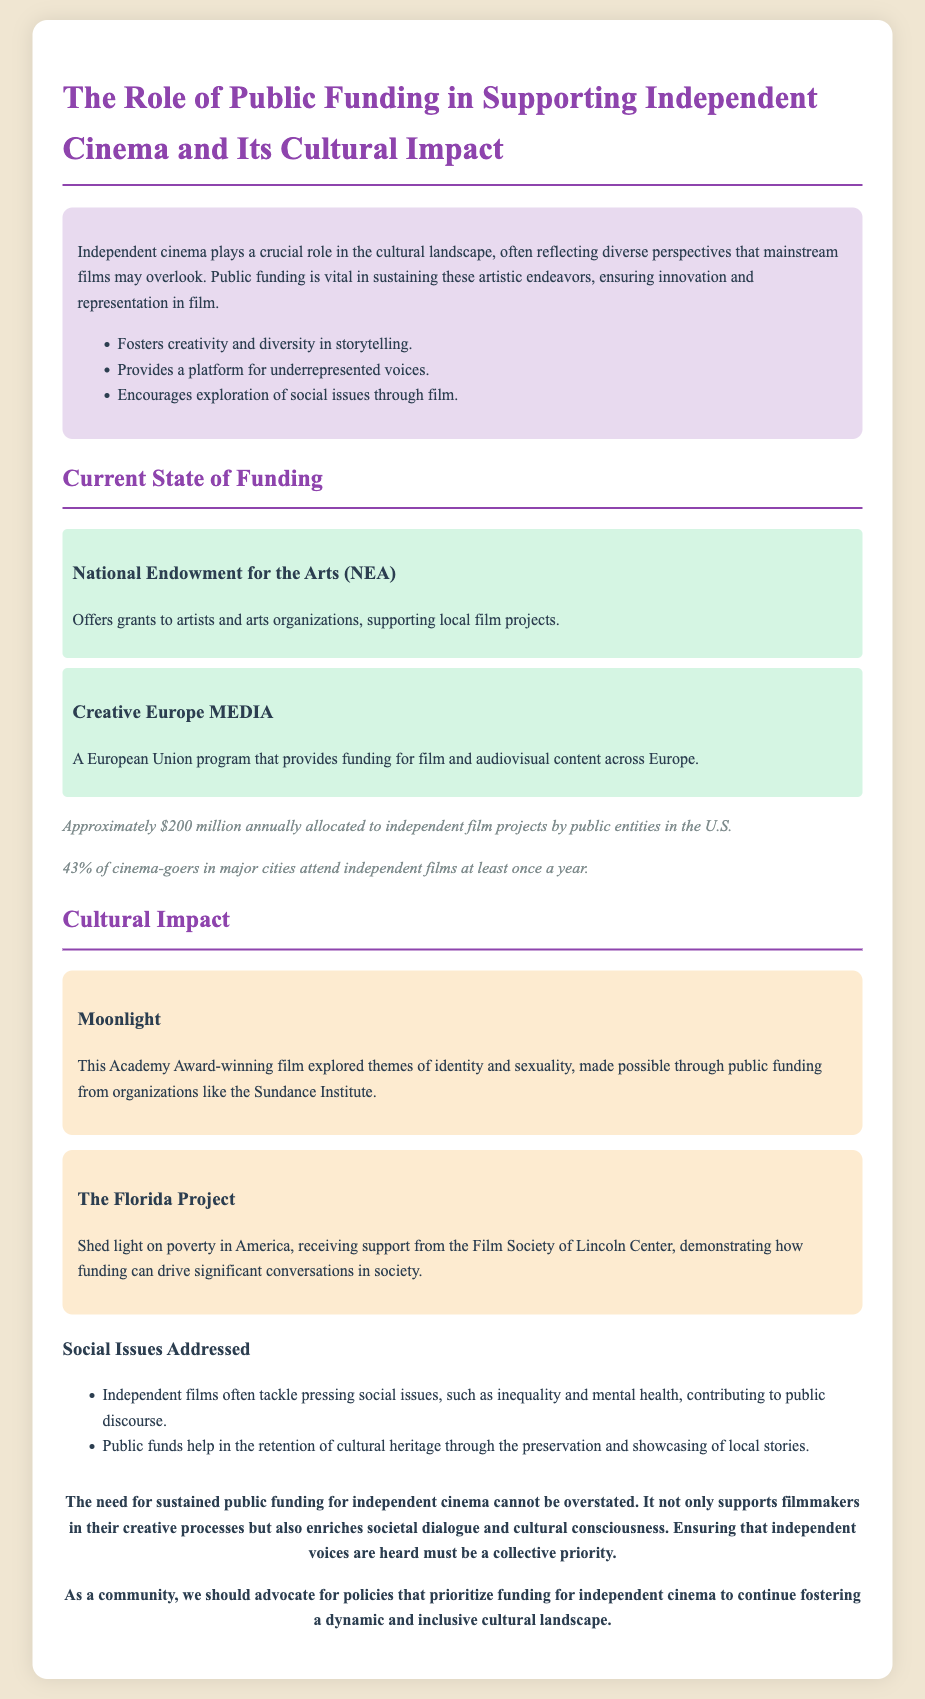What is the purpose of public funding in independent cinema? Public funding sustains artistic endeavors, ensuring innovation and representation in film.
Answer: To sustain artistic endeavors What percentage of cinema-goers in major cities attend independent films yearly? The document states that 43% of cinema-goers in major cities attend independent films at least once a year.
Answer: 43% Which award-winning film explored themes of identity and sexuality? The discussion paper mentions the film "Moonlight" as an example exploring these themes.
Answer: Moonlight What is the annual funding amount allocated to independent film projects in the U.S.? The document indicates that approximately $200 million annually is allocated to independent film projects by public entities.
Answer: $200 million Name one funding source mentioned for supporting local film projects. The document provides multiple funding sources, one of which is the National Endowment for the Arts (NEA).
Answer: National Endowment for the Arts What social issue does "The Florida Project" address? The film "The Florida Project" sheds light on poverty in America, as discussed in the case study.
Answer: Poverty What is the conclusion about public funding for independent cinema? The conclusion emphasizes the necessity for sustained public funding to support filmmakers and enrich societal dialogue.
Answer: It cannot be overstated What does independent cinema foster according to the document? Independent cinema fosters creativity and diversity in storytelling.
Answer: Creativity and diversity 